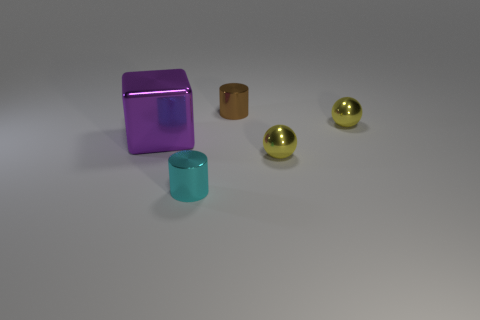There is a tiny thing that is behind the small yellow ball on the right side of the yellow metal object in front of the big cube; what is its shape?
Offer a very short reply. Cylinder. How many other objects are there of the same material as the large block?
Your answer should be compact. 4. Is the material of the small cylinder to the right of the cyan metallic thing the same as the small yellow object that is in front of the large purple object?
Your answer should be very brief. Yes. What number of shiny things are right of the tiny cyan metallic thing and in front of the big shiny object?
Offer a terse response. 1. Are there any other cyan things that have the same shape as the tiny cyan object?
Your response must be concise. No. Is the number of purple metal things that are in front of the large purple shiny cube the same as the number of tiny cyan metal cylinders that are on the left side of the brown cylinder?
Give a very brief answer. No. There is a metal object that is on the left side of the metal cylinder to the left of the tiny brown cylinder; how big is it?
Your answer should be very brief. Large. Are there any purple metal cubes of the same size as the cyan thing?
Give a very brief answer. No. There is another tiny cylinder that is the same material as the brown cylinder; what is its color?
Your answer should be very brief. Cyan. Is the number of cyan cylinders less than the number of metallic objects?
Give a very brief answer. Yes. 